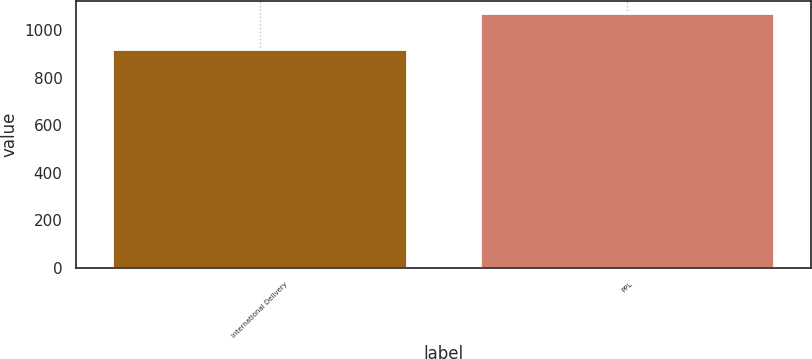Convert chart. <chart><loc_0><loc_0><loc_500><loc_500><bar_chart><fcel>International Delivery<fcel>PPL<nl><fcel>921<fcel>1070<nl></chart> 